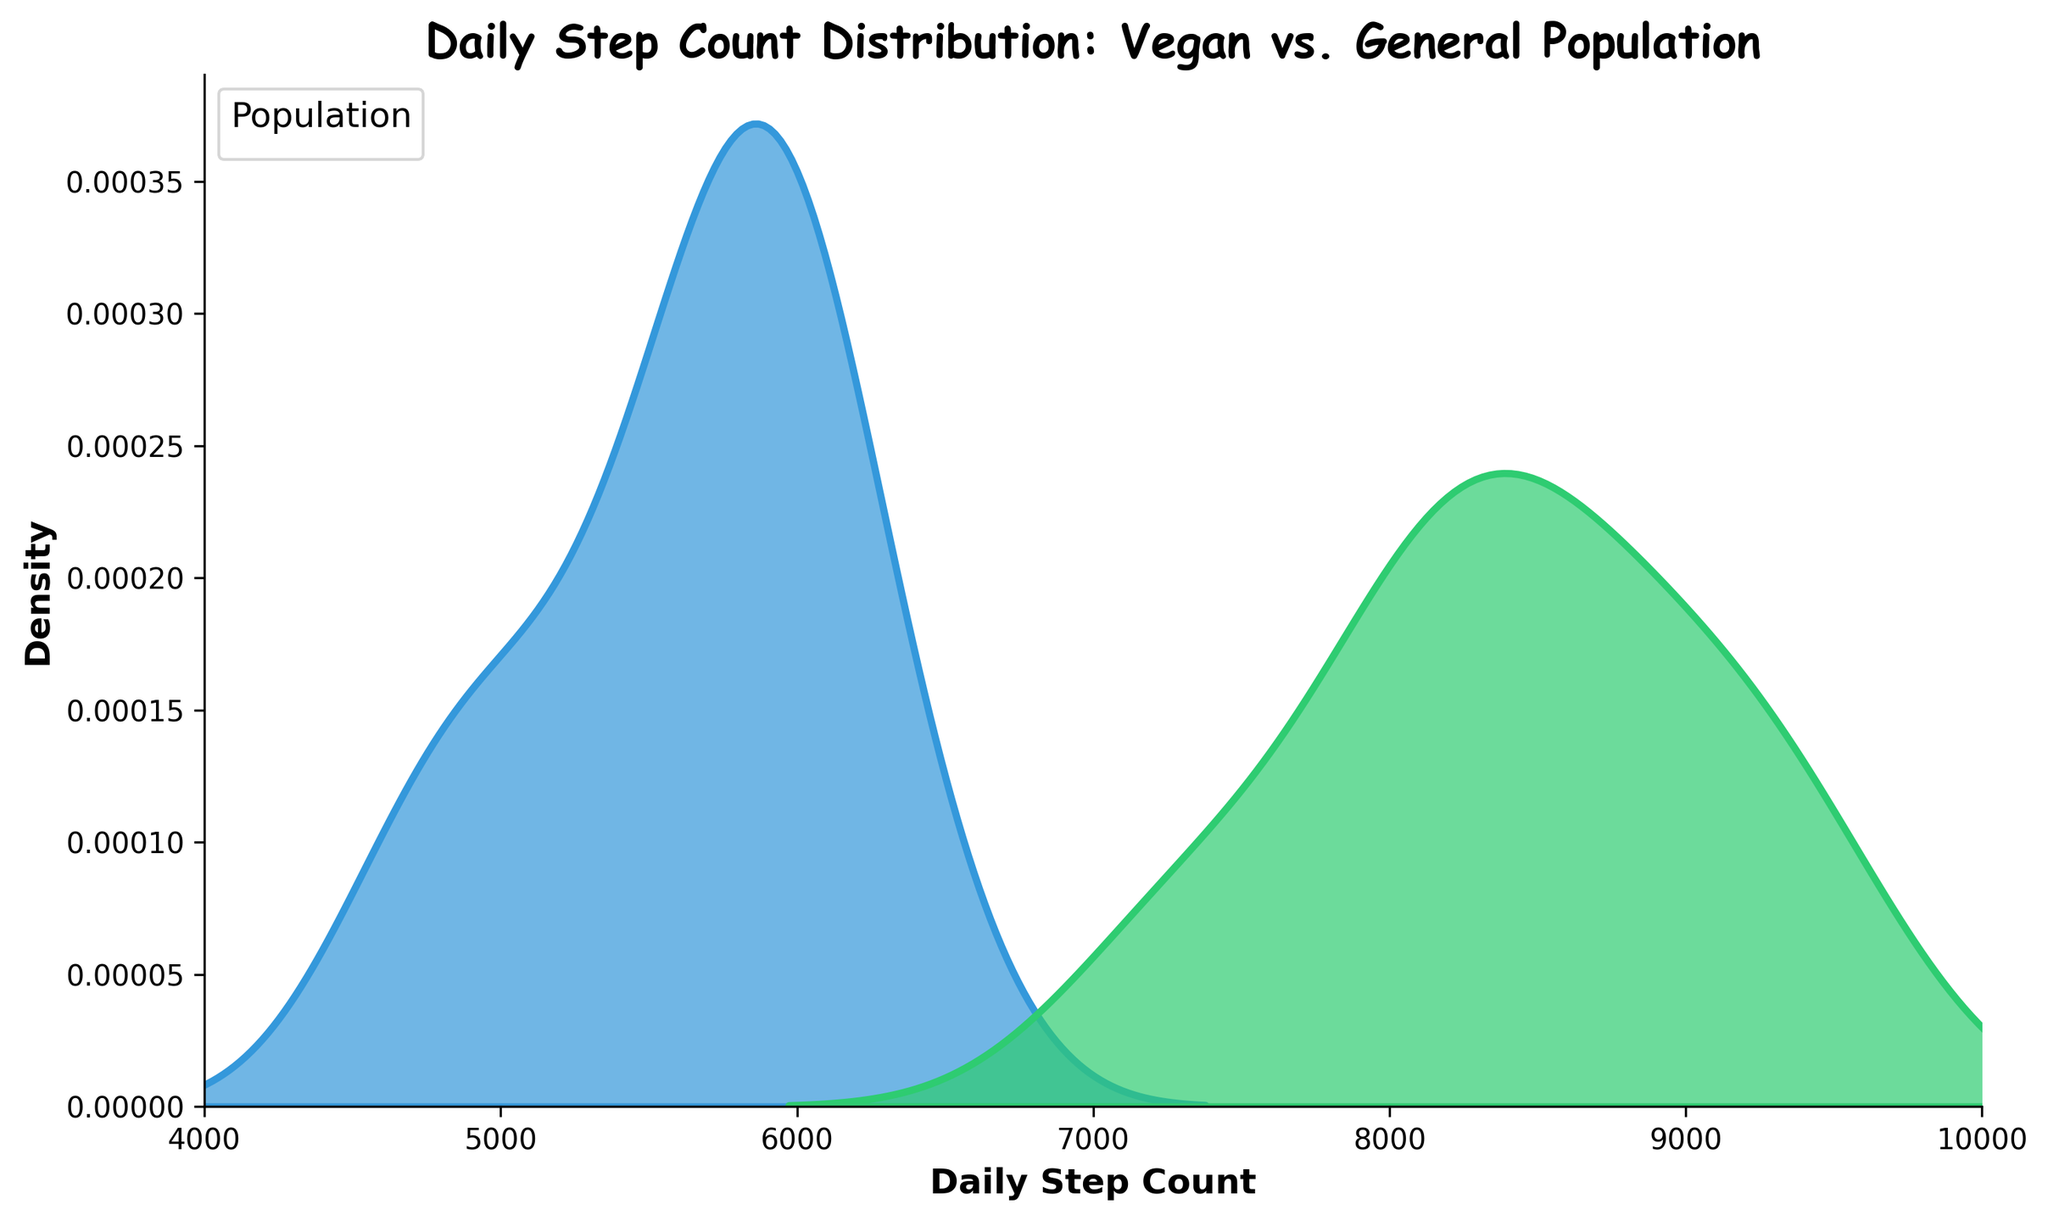What is the title of the plot? The title is displayed at the top center of the plot and reads 'Daily Step Count Distribution: Vegan vs. General Population'.
Answer: Daily Step Count Distribution: Vegan vs. General Population Which population group has a peak at a higher daily step count? By observing the peaks of each density plot line, the Vegan population's peak is at a higher daily step count than the General population's peak.
Answer: Vegan What is the approximate daily step count where the Vegan population peaks? Locate the highest point on the Vegan density curve and trace down to the x-axis to find the corresponding step count, which appears to be at around 8500 steps.
Answer: 8500 steps Between what range do the daily step counts for both populations fall? The x-axis of the plot ranges from 4000 to 10000, and both density lines are confined within this range.
Answer: 4000 to 10000 steps Which population shows a broader spread in daily step counts? By comparing the spread of the density plots, the Vegan group has a narrower and sharper peak suggesting less spread, while the General group has a broader and flatter peak, indicating more spread.
Answer: General What color represents the Vegan population in the plot? From the legend and density fill, the Vegan population is represented by a green shade.
Answer: Green What color represents the General population in the plot? From the legend and density fill, the General population is represented by a blue shade.
Answer: Blue According to the annotation, what is the remark about the Vegan population? The annotation on the plot reads 'Vegans tend to walk more!', emphasizing that the Vegan population generally has a higher daily step count.
Answer: Vegans tend to walk more! Considering the density peaks, which population is likely to have walkers who more consistently hit higher steps per day? The Vegan population's density peak is higher and narrower, indicating more consistency in hitting higher step counts compared to the General population.
Answer: Vegan Are there any daily step count values where both populations have zero density? Observing both density lines, neither touches or gets close to zero within the range shown (4000 to 10000 steps), indicating that members from both populations take at least some steps daily within that range.
Answer: No 